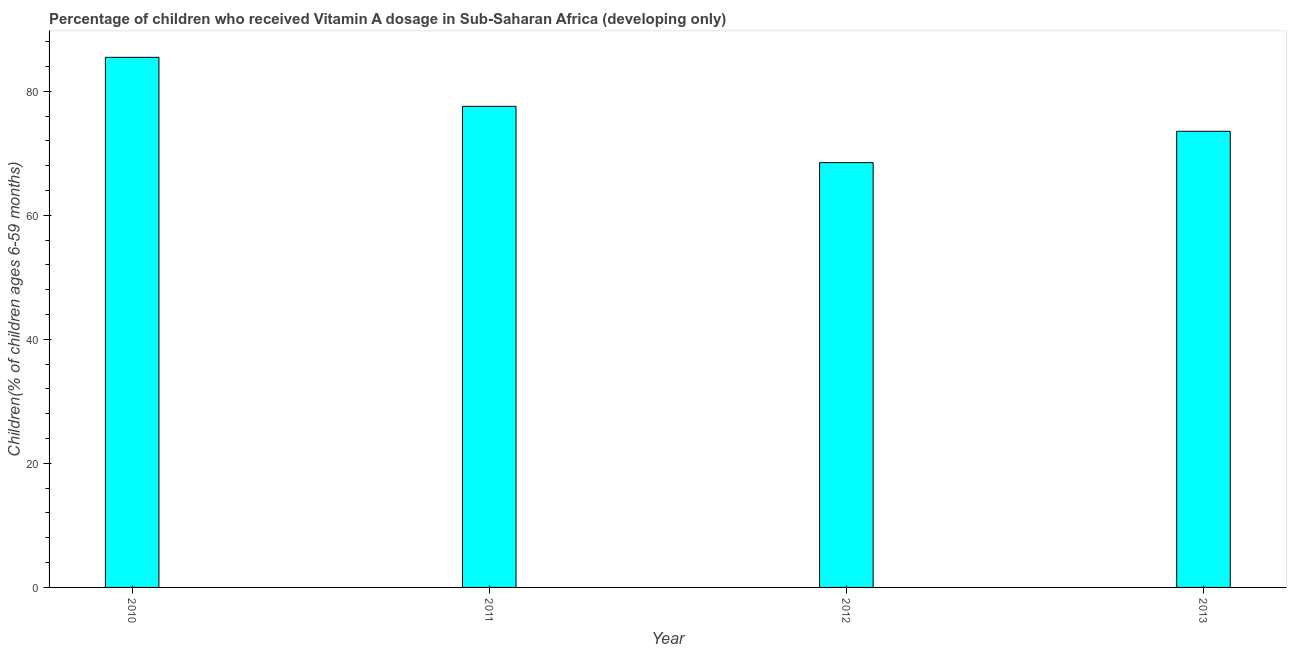Does the graph contain any zero values?
Offer a terse response. No. Does the graph contain grids?
Offer a very short reply. No. What is the title of the graph?
Keep it short and to the point. Percentage of children who received Vitamin A dosage in Sub-Saharan Africa (developing only). What is the label or title of the Y-axis?
Offer a terse response. Children(% of children ages 6-59 months). What is the vitamin a supplementation coverage rate in 2013?
Your response must be concise. 73.54. Across all years, what is the maximum vitamin a supplementation coverage rate?
Make the answer very short. 85.46. Across all years, what is the minimum vitamin a supplementation coverage rate?
Provide a succinct answer. 68.48. What is the sum of the vitamin a supplementation coverage rate?
Your response must be concise. 305.04. What is the difference between the vitamin a supplementation coverage rate in 2010 and 2012?
Give a very brief answer. 16.98. What is the average vitamin a supplementation coverage rate per year?
Make the answer very short. 76.26. What is the median vitamin a supplementation coverage rate?
Make the answer very short. 75.55. In how many years, is the vitamin a supplementation coverage rate greater than 64 %?
Keep it short and to the point. 4. Do a majority of the years between 2013 and 2012 (inclusive) have vitamin a supplementation coverage rate greater than 80 %?
Provide a succinct answer. No. What is the ratio of the vitamin a supplementation coverage rate in 2010 to that in 2012?
Provide a succinct answer. 1.25. What is the difference between the highest and the second highest vitamin a supplementation coverage rate?
Make the answer very short. 7.9. What is the difference between the highest and the lowest vitamin a supplementation coverage rate?
Your response must be concise. 16.98. How many years are there in the graph?
Your answer should be compact. 4. What is the Children(% of children ages 6-59 months) of 2010?
Keep it short and to the point. 85.46. What is the Children(% of children ages 6-59 months) of 2011?
Offer a very short reply. 77.56. What is the Children(% of children ages 6-59 months) in 2012?
Ensure brevity in your answer.  68.48. What is the Children(% of children ages 6-59 months) in 2013?
Give a very brief answer. 73.54. What is the difference between the Children(% of children ages 6-59 months) in 2010 and 2011?
Provide a succinct answer. 7.9. What is the difference between the Children(% of children ages 6-59 months) in 2010 and 2012?
Offer a very short reply. 16.98. What is the difference between the Children(% of children ages 6-59 months) in 2010 and 2013?
Give a very brief answer. 11.92. What is the difference between the Children(% of children ages 6-59 months) in 2011 and 2012?
Your answer should be compact. 9.08. What is the difference between the Children(% of children ages 6-59 months) in 2011 and 2013?
Provide a succinct answer. 4.02. What is the difference between the Children(% of children ages 6-59 months) in 2012 and 2013?
Make the answer very short. -5.05. What is the ratio of the Children(% of children ages 6-59 months) in 2010 to that in 2011?
Provide a short and direct response. 1.1. What is the ratio of the Children(% of children ages 6-59 months) in 2010 to that in 2012?
Provide a short and direct response. 1.25. What is the ratio of the Children(% of children ages 6-59 months) in 2010 to that in 2013?
Your answer should be compact. 1.16. What is the ratio of the Children(% of children ages 6-59 months) in 2011 to that in 2012?
Ensure brevity in your answer.  1.13. What is the ratio of the Children(% of children ages 6-59 months) in 2011 to that in 2013?
Ensure brevity in your answer.  1.05. What is the ratio of the Children(% of children ages 6-59 months) in 2012 to that in 2013?
Your response must be concise. 0.93. 